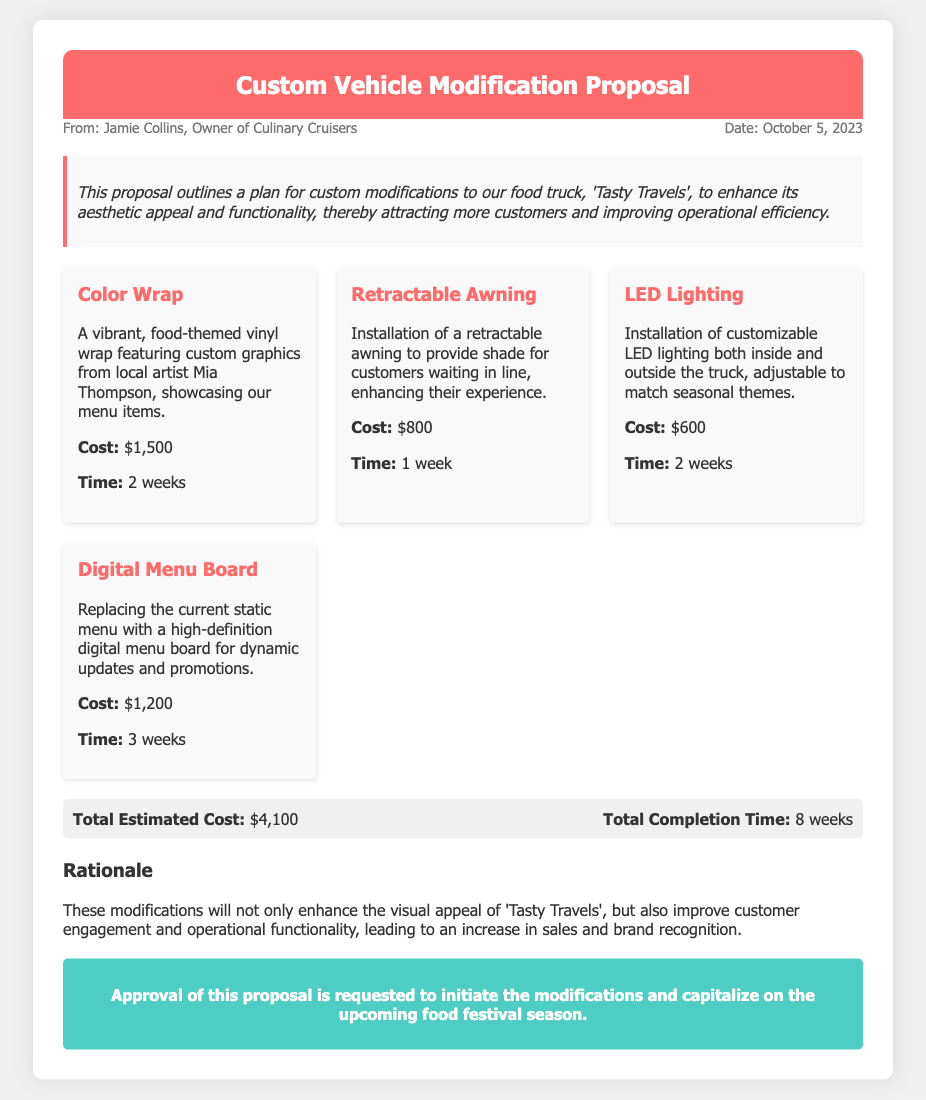What is the name of the food truck? The name of the food truck is mentioned in the introduction as 'Tasty Travels'.
Answer: Tasty Travels Who is the owner of Culinary Cruisers? The document states the owner as Jamie Collins, who is the sender of the proposal.
Answer: Jamie Collins What is the total estimated cost of the modifications? The total estimated cost is summarized in the totals section of the document.
Answer: $4,100 How long is the completion time for all modifications? The total completion time is indicated in the totals section.
Answer: 8 weeks What specific element includes a high-definition feature? The document specifies that the Digital Menu Board involves a high-definition feature for dynamic updates.
Answer: Digital Menu Board What is the purpose of the retractable awning? The retractable awning is intended to provide shade for customers waiting in line, thereby enhancing their experience.
Answer: Provide shade How much will the LED lighting cost? The cost of the LED lighting is listed in the design elements section.
Answer: $600 What is the rationale behind the modifications? The rationale provides insights into how the modifications will enhance visual appeal and functionality.
Answer: Increase in sales How many design elements are proposed in total? The document lists four distinct design elements for modification.
Answer: Four 